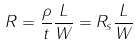<formula> <loc_0><loc_0><loc_500><loc_500>R = \frac { \rho } { t } \frac { L } { W } = R _ { s } \frac { L } { W }</formula> 